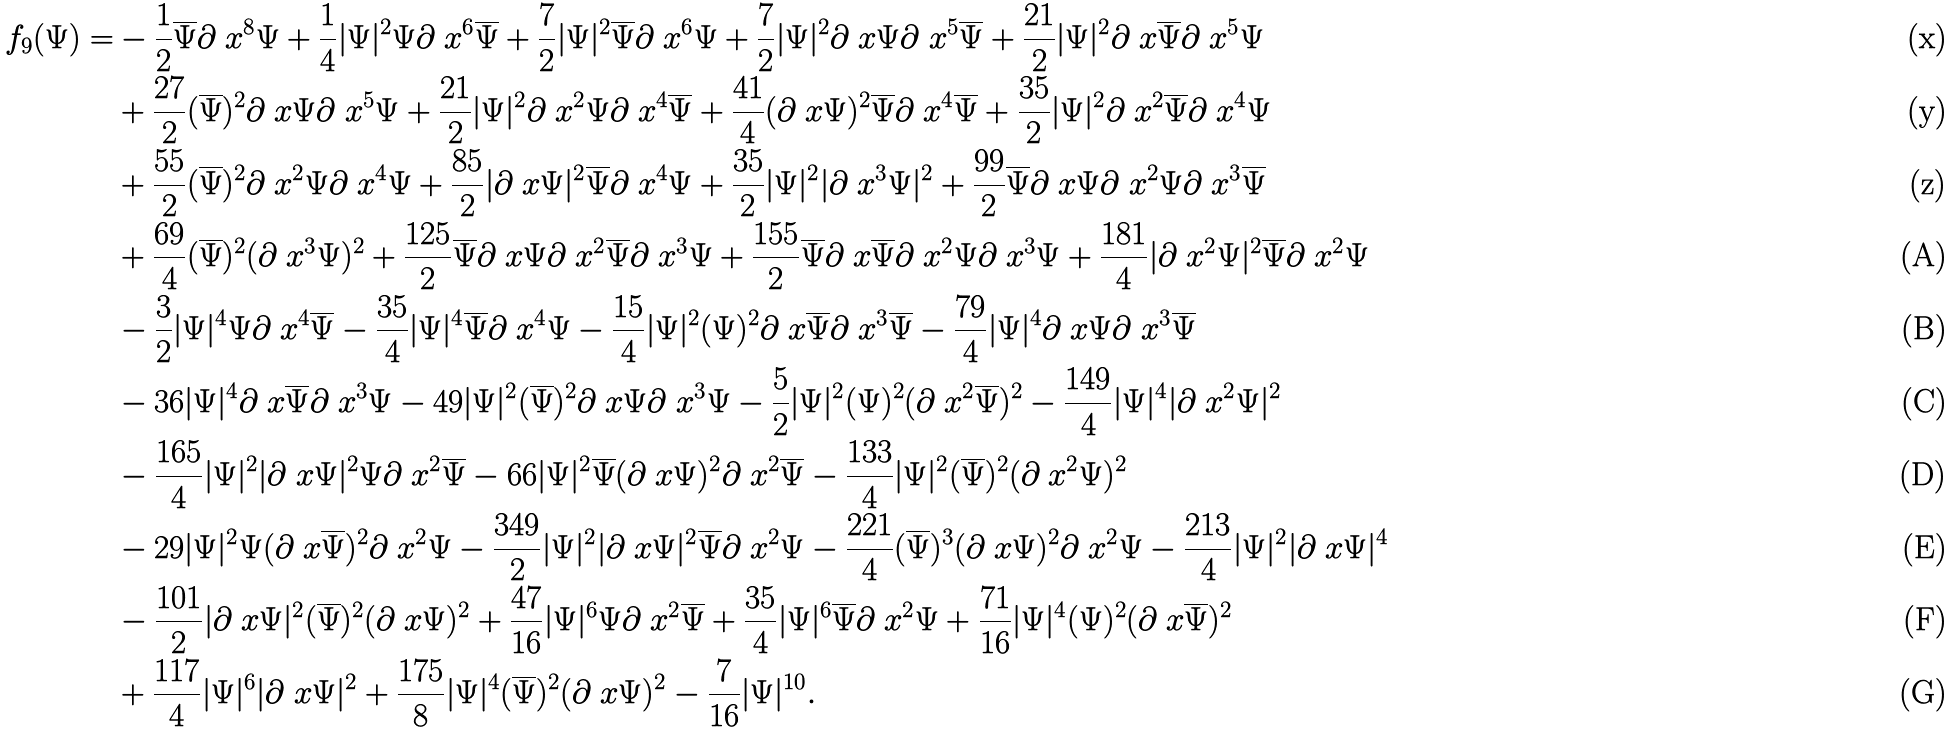Convert formula to latex. <formula><loc_0><loc_0><loc_500><loc_500>f _ { 9 } ( \Psi ) = & - \frac { 1 } { 2 } \overline { \Psi } \partial _ { \ } x ^ { 8 } \Psi + \frac { 1 } { 4 } | \Psi | ^ { 2 } \Psi \partial _ { \ } x ^ { 6 } \overline { \Psi } + \frac { 7 } { 2 } | \Psi | ^ { 2 } \overline { \Psi } \partial _ { \ } x ^ { 6 } \Psi + \frac { 7 } { 2 } | \Psi | ^ { 2 } \partial _ { \ } x \Psi \partial _ { \ } x ^ { 5 } \overline { \Psi } + \frac { 2 1 } { 2 } | \Psi | ^ { 2 } \partial _ { \ } x \overline { \Psi } \partial _ { \ } x ^ { 5 } \Psi \\ & + \frac { 2 7 } { 2 } ( \overline { \Psi } ) ^ { 2 } \partial _ { \ } x \Psi \partial _ { \ } x ^ { 5 } \Psi + \frac { 2 1 } { 2 } | \Psi | ^ { 2 } \partial _ { \ } x ^ { 2 } \Psi \partial _ { \ } x ^ { 4 } \overline { \Psi } + \frac { 4 1 } { 4 } ( \partial _ { \ } x \Psi ) ^ { 2 } \overline { \Psi } \partial _ { \ } x ^ { 4 } \overline { \Psi } + \frac { 3 5 } { 2 } | \Psi | ^ { 2 } \partial _ { \ } x ^ { 2 } \overline { \Psi } \partial _ { \ } x ^ { 4 } \Psi \\ & + \frac { 5 5 } { 2 } ( \overline { \Psi } ) ^ { 2 } \partial _ { \ } x ^ { 2 } \Psi \partial _ { \ } x ^ { 4 } \Psi + \frac { 8 5 } { 2 } | \partial _ { \ } x \Psi | ^ { 2 } \overline { \Psi } \partial _ { \ } x ^ { 4 } \Psi + \frac { 3 5 } { 2 } | \Psi | ^ { 2 } | \partial _ { \ } x ^ { 3 } \Psi | ^ { 2 } + \frac { 9 9 } { 2 } \overline { \Psi } \partial _ { \ } x \Psi \partial _ { \ } x ^ { 2 } \Psi \partial _ { \ } x ^ { 3 } \overline { \Psi } \\ & + \frac { 6 9 } { 4 } ( \overline { \Psi } ) ^ { 2 } ( \partial _ { \ } x ^ { 3 } \Psi ) ^ { 2 } + \frac { 1 2 5 } { 2 } \overline { \Psi } \partial _ { \ } x \Psi \partial _ { \ } x ^ { 2 } \overline { \Psi } \partial _ { \ } x ^ { 3 } \Psi + \frac { 1 5 5 } { 2 } \overline { \Psi } \partial _ { \ } x \overline { \Psi } \partial _ { \ } x ^ { 2 } \Psi \partial _ { \ } x ^ { 3 } \Psi + \frac { 1 8 1 } { 4 } | \partial _ { \ } x ^ { 2 } \Psi | ^ { 2 } \overline { \Psi } \partial _ { \ } x ^ { 2 } \Psi \\ & - \frac { 3 } { 2 } | \Psi | ^ { 4 } \Psi \partial _ { \ } x ^ { 4 } \overline { \Psi } - \frac { 3 5 } { 4 } | \Psi | ^ { 4 } \overline { \Psi } \partial _ { \ } x ^ { 4 } \Psi - \frac { 1 5 } { 4 } | \Psi | ^ { 2 } ( \Psi ) ^ { 2 } \partial _ { \ } x \overline { \Psi } \partial _ { \ } x ^ { 3 } \overline { \Psi } - \frac { 7 9 } { 4 } | \Psi | ^ { 4 } \partial _ { \ } x \Psi \partial _ { \ } x ^ { 3 } \overline { \Psi } \\ & - 3 6 | \Psi | ^ { 4 } \partial _ { \ } x \overline { \Psi } \partial _ { \ } x ^ { 3 } \Psi - 4 9 | \Psi | ^ { 2 } ( \overline { \Psi } ) ^ { 2 } \partial _ { \ } x \Psi \partial _ { \ } x ^ { 3 } \Psi - \frac { 5 } { 2 } | \Psi | ^ { 2 } ( \Psi ) ^ { 2 } ( \partial _ { \ } x ^ { 2 } \overline { \Psi } ) ^ { 2 } - \frac { 1 4 9 } { 4 } | \Psi | ^ { 4 } | \partial _ { \ } x ^ { 2 } \Psi | ^ { 2 } \\ & - \frac { 1 6 5 } { 4 } | \Psi | ^ { 2 } | \partial _ { \ } x \Psi | ^ { 2 } \Psi \partial _ { \ } x ^ { 2 } \overline { \Psi } - 6 6 | \Psi | ^ { 2 } \overline { \Psi } ( \partial _ { \ } x \Psi ) ^ { 2 } \partial _ { \ } x ^ { 2 } \overline { \Psi } - \frac { 1 3 3 } { 4 } | \Psi | ^ { 2 } ( \overline { \Psi } ) ^ { 2 } ( \partial _ { \ } x ^ { 2 } \Psi ) ^ { 2 } \\ & - 2 9 | \Psi | ^ { 2 } \Psi ( \partial _ { \ } x \overline { \Psi } ) ^ { 2 } \partial _ { \ } x ^ { 2 } \Psi - \frac { 3 4 9 } { 2 } | \Psi | ^ { 2 } | \partial _ { \ } x \Psi | ^ { 2 } \overline { \Psi } \partial _ { \ } x ^ { 2 } \Psi - \frac { 2 2 1 } { 4 } ( \overline { \Psi } ) ^ { 3 } ( \partial _ { \ } x \Psi ) ^ { 2 } \partial _ { \ } x ^ { 2 } \Psi - \frac { 2 1 3 } { 4 } | \Psi | ^ { 2 } | \partial _ { \ } x \Psi | ^ { 4 } \\ & - \frac { 1 0 1 } { 2 } | \partial _ { \ } x \Psi | ^ { 2 } ( \overline { \Psi } ) ^ { 2 } ( \partial _ { \ } x \Psi ) ^ { 2 } + \frac { 4 7 } { 1 6 } | \Psi | ^ { 6 } \Psi \partial _ { \ } x ^ { 2 } \overline { \Psi } + \frac { 3 5 } { 4 } | \Psi | ^ { 6 } \overline { \Psi } \partial _ { \ } x ^ { 2 } \Psi + \frac { 7 1 } { 1 6 } | \Psi | ^ { 4 } ( \Psi ) ^ { 2 } ( \partial _ { \ } x \overline { \Psi } ) ^ { 2 } \\ & + \frac { 1 1 7 } { 4 } | \Psi | ^ { 6 } | \partial _ { \ } x \Psi | ^ { 2 } + \frac { 1 7 5 } { 8 } | \Psi | ^ { 4 } ( \overline { \Psi } ) ^ { 2 } ( \partial _ { \ } x \Psi ) ^ { 2 } - \frac { 7 } { 1 6 } | \Psi | ^ { 1 0 } .</formula> 